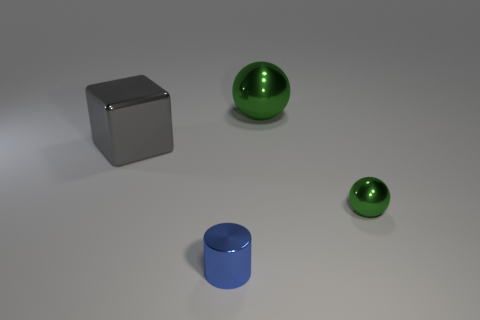Subtract all cyan blocks. Subtract all cyan spheres. How many blocks are left? 1 Add 2 gray metal blocks. How many objects exist? 6 Subtract all cylinders. How many objects are left? 3 Subtract 0 yellow cubes. How many objects are left? 4 Subtract all small balls. Subtract all tiny yellow metal objects. How many objects are left? 3 Add 2 cylinders. How many cylinders are left? 3 Add 1 blue spheres. How many blue spheres exist? 1 